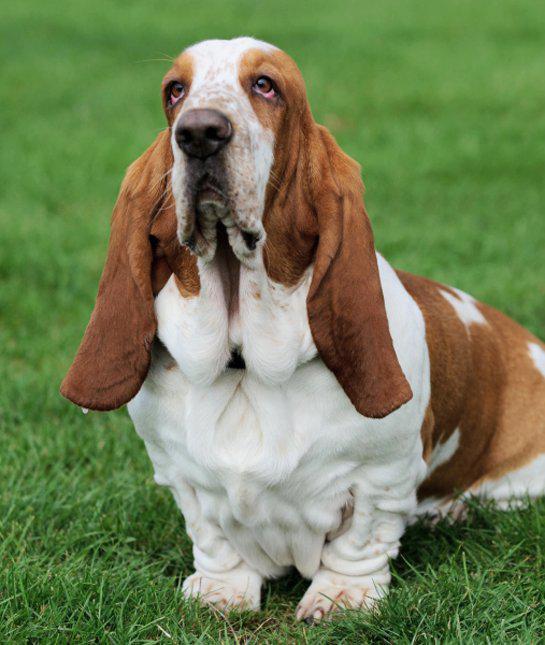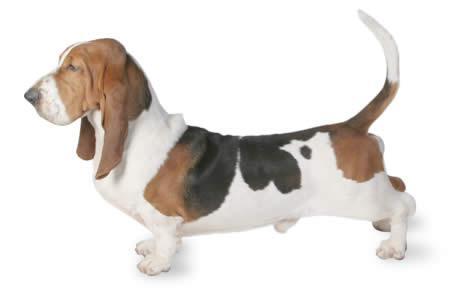The first image is the image on the left, the second image is the image on the right. Considering the images on both sides, is "An image shows a brown and white basset on grass in profile facing left." valid? Answer yes or no. No. 